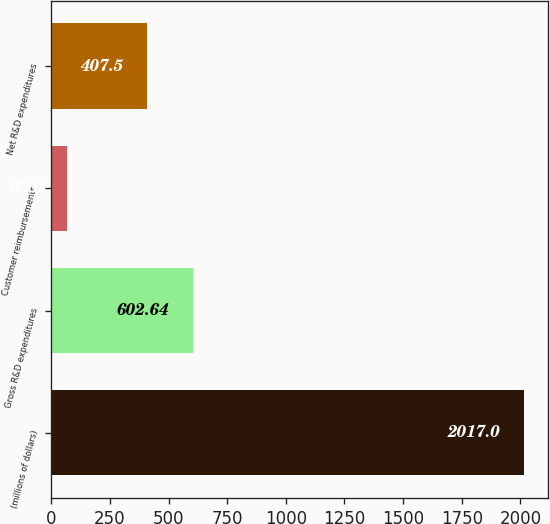Convert chart to OTSL. <chart><loc_0><loc_0><loc_500><loc_500><bar_chart><fcel>(millions of dollars)<fcel>Gross R&D expenditures<fcel>Customer reimbursements<fcel>Net R&D expenditures<nl><fcel>2017<fcel>602.64<fcel>65.6<fcel>407.5<nl></chart> 